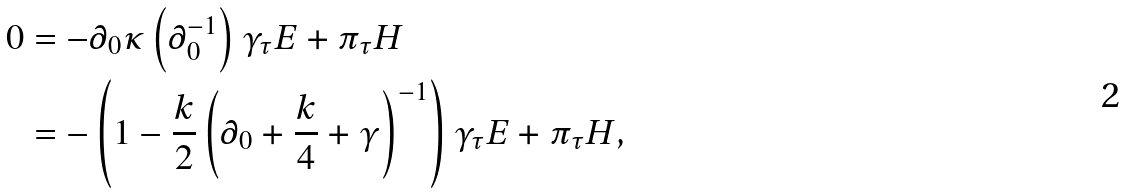<formula> <loc_0><loc_0><loc_500><loc_500>0 & = - \partial _ { 0 } \kappa \left ( \partial _ { 0 } ^ { - 1 } \right ) \gamma _ { \tau } E + \pi _ { \tau } H \\ & = - \left ( 1 - \frac { k } { 2 } \left ( \partial _ { 0 } + \frac { k } { 4 } + \gamma \right ) ^ { - 1 } \right ) \gamma _ { \tau } E + \pi _ { \tau } H ,</formula> 